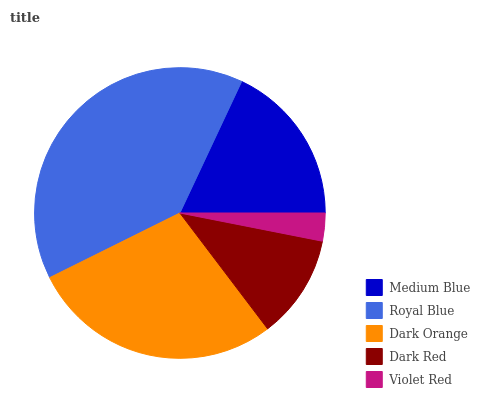Is Violet Red the minimum?
Answer yes or no. Yes. Is Royal Blue the maximum?
Answer yes or no. Yes. Is Dark Orange the minimum?
Answer yes or no. No. Is Dark Orange the maximum?
Answer yes or no. No. Is Royal Blue greater than Dark Orange?
Answer yes or no. Yes. Is Dark Orange less than Royal Blue?
Answer yes or no. Yes. Is Dark Orange greater than Royal Blue?
Answer yes or no. No. Is Royal Blue less than Dark Orange?
Answer yes or no. No. Is Medium Blue the high median?
Answer yes or no. Yes. Is Medium Blue the low median?
Answer yes or no. Yes. Is Dark Orange the high median?
Answer yes or no. No. Is Royal Blue the low median?
Answer yes or no. No. 